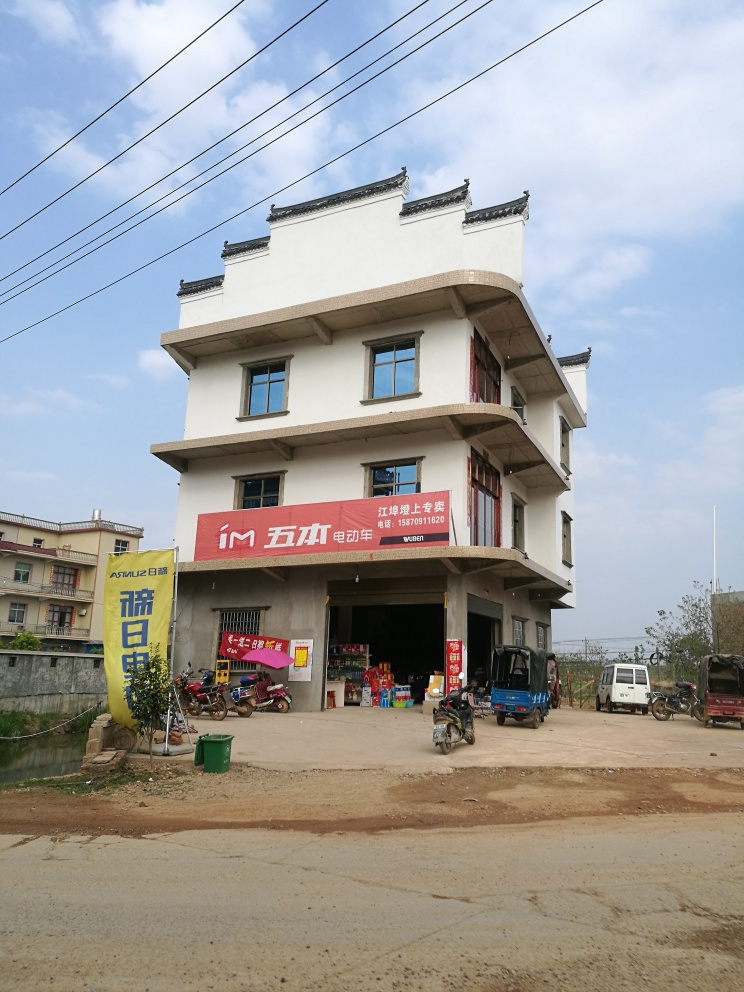Describe the style and notable features of the building in this image. The building in the image exhibits a modern design with traditional influences, likely found in a suburban or rural area. The most notable features are its multi-tiered roof with upturned edges, white facade, and a prominent ground floor that appears to serve as a commercial space, marked by red signage and an open storefront. 